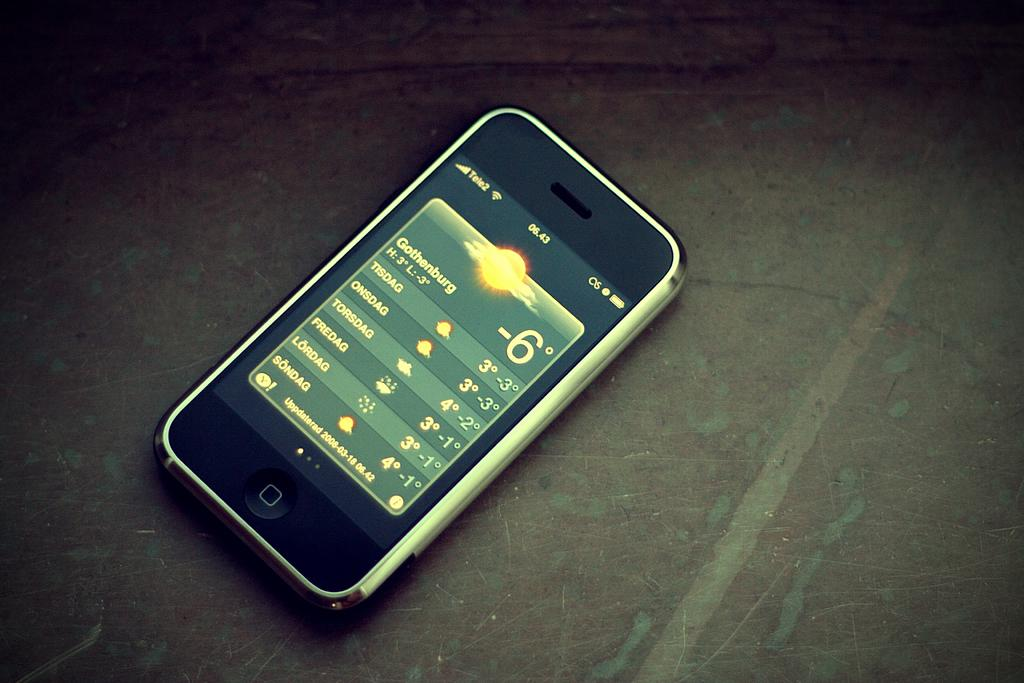<image>
Write a terse but informative summary of the picture. A phone screen showing the weather and displaying the time of 06.43 